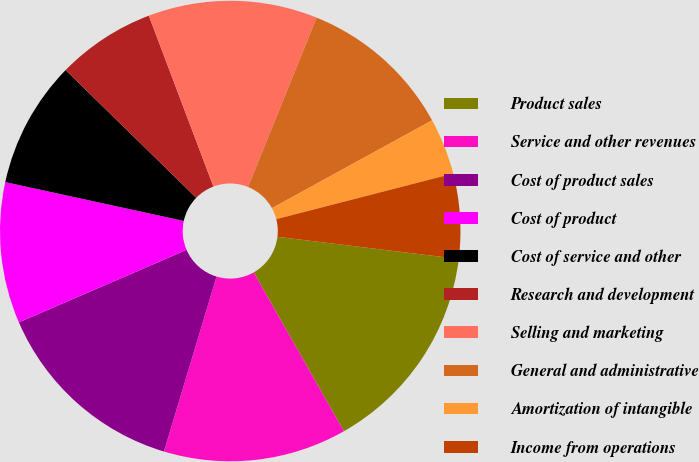<chart> <loc_0><loc_0><loc_500><loc_500><pie_chart><fcel>Product sales<fcel>Service and other revenues<fcel>Cost of product sales<fcel>Cost of product<fcel>Cost of service and other<fcel>Research and development<fcel>Selling and marketing<fcel>General and administrative<fcel>Amortization of intangible<fcel>Income from operations<nl><fcel>14.85%<fcel>12.87%<fcel>13.86%<fcel>9.9%<fcel>8.91%<fcel>6.93%<fcel>11.88%<fcel>10.89%<fcel>3.97%<fcel>5.95%<nl></chart> 